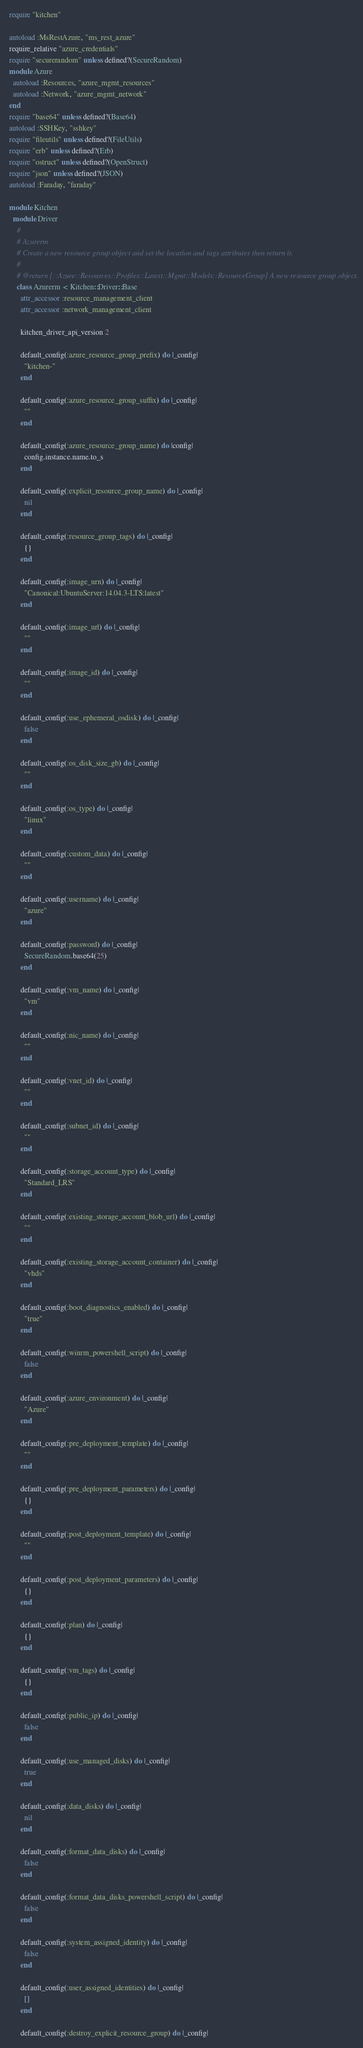<code> <loc_0><loc_0><loc_500><loc_500><_Ruby_>require "kitchen"

autoload :MsRestAzure, "ms_rest_azure"
require_relative "azure_credentials"
require "securerandom" unless defined?(SecureRandom)
module Azure
  autoload :Resources, "azure_mgmt_resources"
  autoload :Network, "azure_mgmt_network"
end
require "base64" unless defined?(Base64)
autoload :SSHKey, "sshkey"
require "fileutils" unless defined?(FileUtils)
require "erb" unless defined?(Erb)
require "ostruct" unless defined?(OpenStruct)
require "json" unless defined?(JSON)
autoload :Faraday, "faraday"

module Kitchen
  module Driver
    #
    # Azurerm
    # Create a new resource group object and set the location and tags attributes then return it.
    #
    # @return [::Azure::Resources::Profiles::Latest::Mgmt::Models::ResourceGroup] A new resource group object.
    class Azurerm < Kitchen::Driver::Base
      attr_accessor :resource_management_client
      attr_accessor :network_management_client

      kitchen_driver_api_version 2

      default_config(:azure_resource_group_prefix) do |_config|
        "kitchen-"
      end

      default_config(:azure_resource_group_suffix) do |_config|
        ""
      end

      default_config(:azure_resource_group_name) do |config|
        config.instance.name.to_s
      end

      default_config(:explicit_resource_group_name) do |_config|
        nil
      end

      default_config(:resource_group_tags) do |_config|
        {}
      end

      default_config(:image_urn) do |_config|
        "Canonical:UbuntuServer:14.04.3-LTS:latest"
      end

      default_config(:image_url) do |_config|
        ""
      end

      default_config(:image_id) do |_config|
        ""
      end

      default_config(:use_ephemeral_osdisk) do |_config|
        false
      end

      default_config(:os_disk_size_gb) do |_config|
        ""
      end

      default_config(:os_type) do |_config|
        "linux"
      end

      default_config(:custom_data) do |_config|
        ""
      end

      default_config(:username) do |_config|
        "azure"
      end

      default_config(:password) do |_config|
        SecureRandom.base64(25)
      end

      default_config(:vm_name) do |_config|
        "vm"
      end

      default_config(:nic_name) do |_config|
        ""
      end

      default_config(:vnet_id) do |_config|
        ""
      end

      default_config(:subnet_id) do |_config|
        ""
      end

      default_config(:storage_account_type) do |_config|
        "Standard_LRS"
      end

      default_config(:existing_storage_account_blob_url) do |_config|
        ""
      end

      default_config(:existing_storage_account_container) do |_config|
        "vhds"
      end

      default_config(:boot_diagnostics_enabled) do |_config|
        "true"
      end

      default_config(:winrm_powershell_script) do |_config|
        false
      end

      default_config(:azure_environment) do |_config|
        "Azure"
      end

      default_config(:pre_deployment_template) do |_config|
        ""
      end

      default_config(:pre_deployment_parameters) do |_config|
        {}
      end

      default_config(:post_deployment_template) do |_config|
        ""
      end

      default_config(:post_deployment_parameters) do |_config|
        {}
      end

      default_config(:plan) do |_config|
        {}
      end

      default_config(:vm_tags) do |_config|
        {}
      end

      default_config(:public_ip) do |_config|
        false
      end

      default_config(:use_managed_disks) do |_config|
        true
      end

      default_config(:data_disks) do |_config|
        nil
      end

      default_config(:format_data_disks) do |_config|
        false
      end

      default_config(:format_data_disks_powershell_script) do |_config|
        false
      end

      default_config(:system_assigned_identity) do |_config|
        false
      end

      default_config(:user_assigned_identities) do |_config|
        []
      end

      default_config(:destroy_explicit_resource_group) do |_config|</code> 